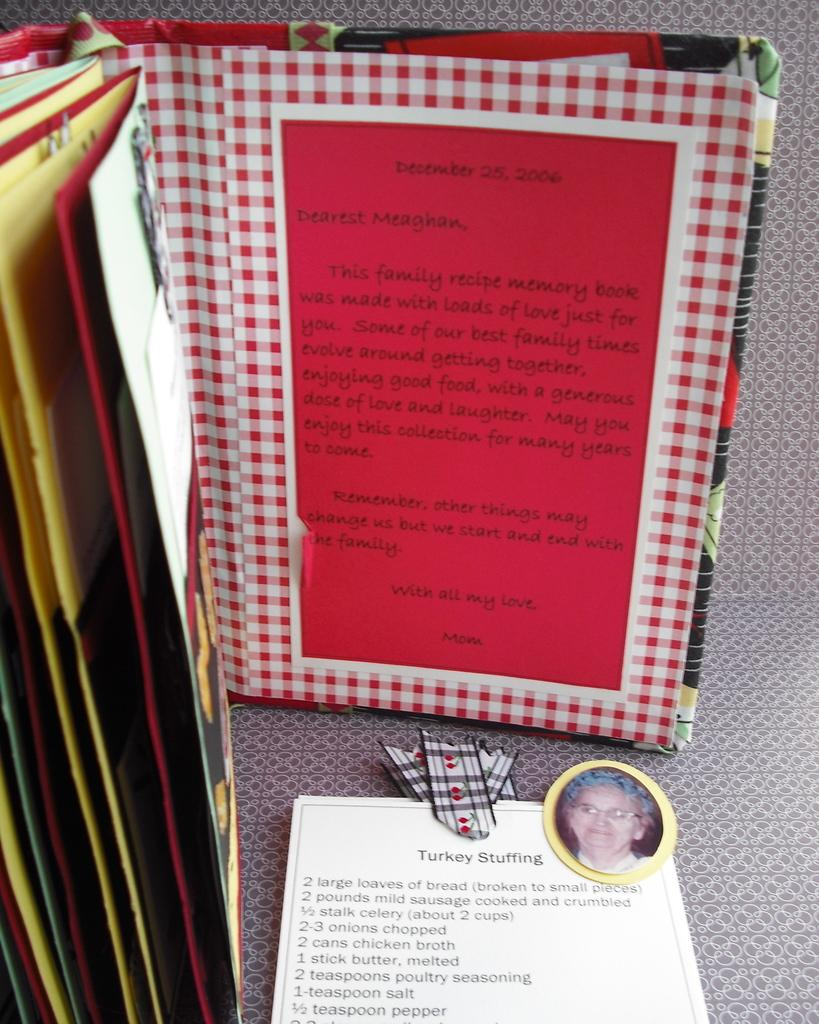What is the main object in the image? There is a book in the image. What else can be seen at the bottom of the image? There is a paper at the bottom of the image. What is depicted on the paper? The paper contains a picture and some text. What type of cloth is used to express anger in the image? There is no cloth or expression of anger present in the image. 